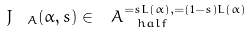Convert formula to latex. <formula><loc_0><loc_0><loc_500><loc_500>J _ { \ A } ( \alpha , s ) \in \ A _ { \ h a l f } ^ { = s L ( \alpha ) , = ( 1 - s ) L ( \alpha ) }</formula> 